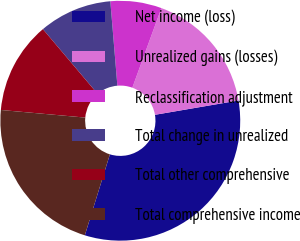Convert chart to OTSL. <chart><loc_0><loc_0><loc_500><loc_500><pie_chart><fcel>Net income (loss)<fcel>Unrealized gains (losses)<fcel>Reclassification adjustment<fcel>Total change in unrealized<fcel>Total other comprehensive<fcel>Total comprehensive income<nl><fcel>32.48%<fcel>16.73%<fcel>6.89%<fcel>9.84%<fcel>12.4%<fcel>21.65%<nl></chart> 